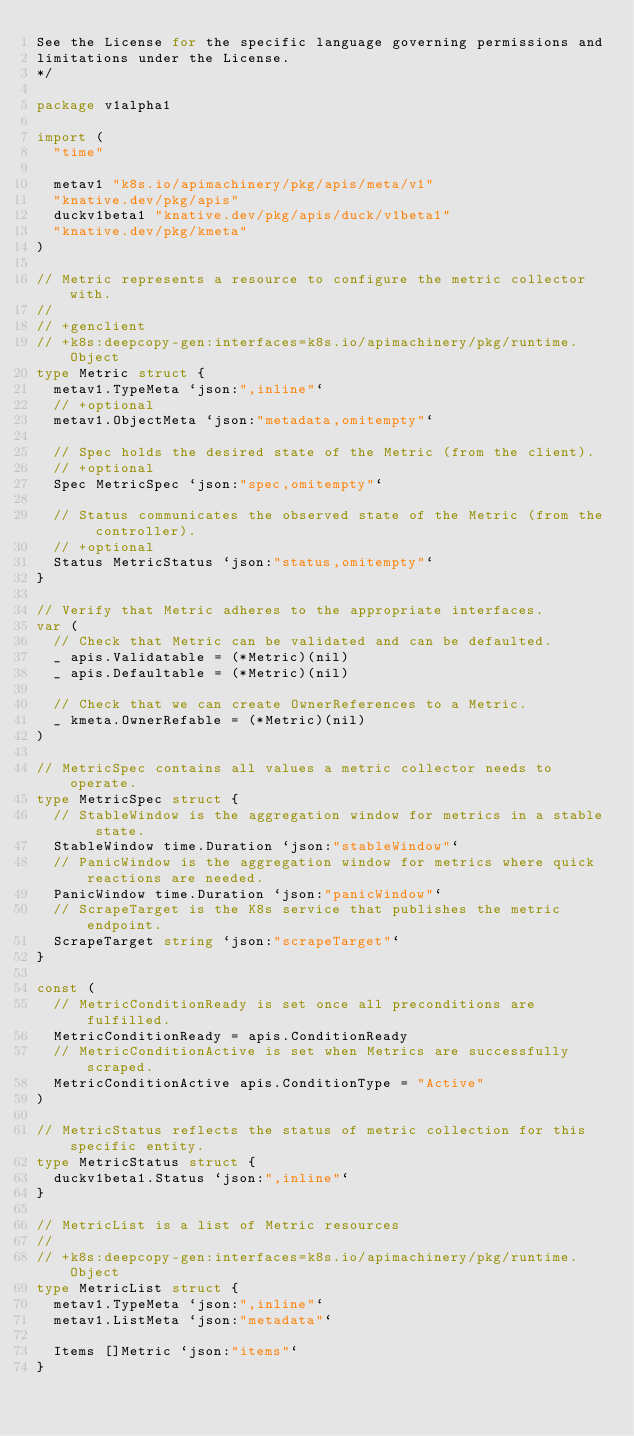Convert code to text. <code><loc_0><loc_0><loc_500><loc_500><_Go_>See the License for the specific language governing permissions and
limitations under the License.
*/

package v1alpha1

import (
	"time"

	metav1 "k8s.io/apimachinery/pkg/apis/meta/v1"
	"knative.dev/pkg/apis"
	duckv1beta1 "knative.dev/pkg/apis/duck/v1beta1"
	"knative.dev/pkg/kmeta"
)

// Metric represents a resource to configure the metric collector with.
//
// +genclient
// +k8s:deepcopy-gen:interfaces=k8s.io/apimachinery/pkg/runtime.Object
type Metric struct {
	metav1.TypeMeta `json:",inline"`
	// +optional
	metav1.ObjectMeta `json:"metadata,omitempty"`

	// Spec holds the desired state of the Metric (from the client).
	// +optional
	Spec MetricSpec `json:"spec,omitempty"`

	// Status communicates the observed state of the Metric (from the controller).
	// +optional
	Status MetricStatus `json:"status,omitempty"`
}

// Verify that Metric adheres to the appropriate interfaces.
var (
	// Check that Metric can be validated and can be defaulted.
	_ apis.Validatable = (*Metric)(nil)
	_ apis.Defaultable = (*Metric)(nil)

	// Check that we can create OwnerReferences to a Metric.
	_ kmeta.OwnerRefable = (*Metric)(nil)
)

// MetricSpec contains all values a metric collector needs to operate.
type MetricSpec struct {
	// StableWindow is the aggregation window for metrics in a stable state.
	StableWindow time.Duration `json:"stableWindow"`
	// PanicWindow is the aggregation window for metrics where quick reactions are needed.
	PanicWindow time.Duration `json:"panicWindow"`
	// ScrapeTarget is the K8s service that publishes the metric endpoint.
	ScrapeTarget string `json:"scrapeTarget"`
}

const (
	// MetricConditionReady is set once all preconditions are fulfilled.
	MetricConditionReady = apis.ConditionReady
	// MetricConditionActive is set when Metrics are successfully scraped.
	MetricConditionActive apis.ConditionType = "Active"
)

// MetricStatus reflects the status of metric collection for this specific entity.
type MetricStatus struct {
	duckv1beta1.Status `json:",inline"`
}

// MetricList is a list of Metric resources
//
// +k8s:deepcopy-gen:interfaces=k8s.io/apimachinery/pkg/runtime.Object
type MetricList struct {
	metav1.TypeMeta `json:",inline"`
	metav1.ListMeta `json:"metadata"`

	Items []Metric `json:"items"`
}
</code> 